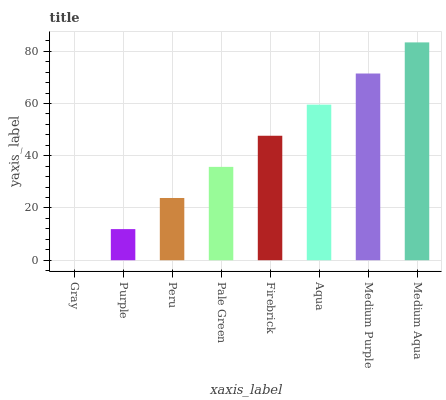Is Purple the minimum?
Answer yes or no. No. Is Purple the maximum?
Answer yes or no. No. Is Purple greater than Gray?
Answer yes or no. Yes. Is Gray less than Purple?
Answer yes or no. Yes. Is Gray greater than Purple?
Answer yes or no. No. Is Purple less than Gray?
Answer yes or no. No. Is Firebrick the high median?
Answer yes or no. Yes. Is Pale Green the low median?
Answer yes or no. Yes. Is Medium Purple the high median?
Answer yes or no. No. Is Peru the low median?
Answer yes or no. No. 